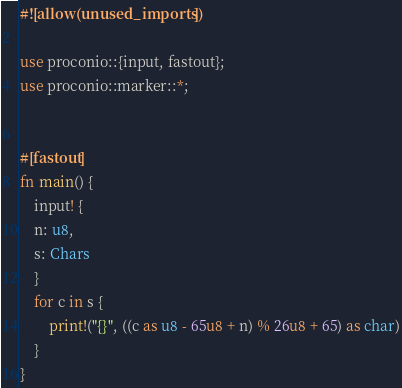Convert code to text. <code><loc_0><loc_0><loc_500><loc_500><_Rust_>#![allow(unused_imports)]

use proconio::{input, fastout};
use proconio::marker::*;


#[fastout]
fn main() {
    input! {
    n: u8,
    s: Chars
    }
    for c in s {
        print!("{}", ((c as u8 - 65u8 + n) % 26u8 + 65) as char)
    }
}
</code> 